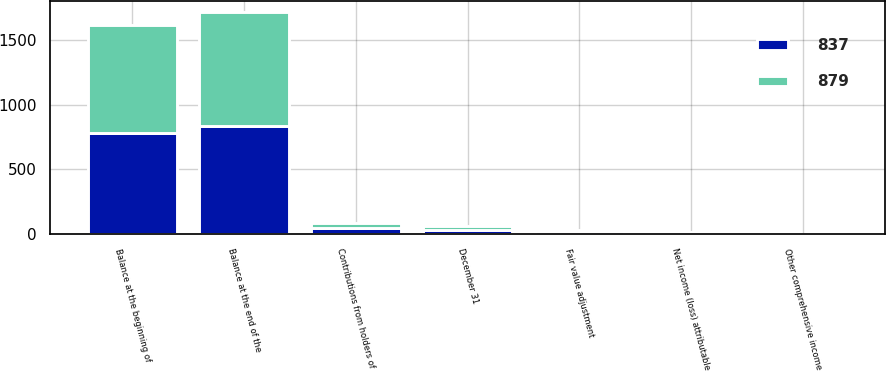Convert chart. <chart><loc_0><loc_0><loc_500><loc_500><stacked_bar_chart><ecel><fcel>December 31<fcel>Balance at the beginning of<fcel>Contributions from holders of<fcel>Net income (loss) attributable<fcel>Fair value adjustment<fcel>Other comprehensive income<fcel>Balance at the end of the<nl><fcel>879<fcel>29.5<fcel>837<fcel>34<fcel>2<fcel>4<fcel>2<fcel>879<nl><fcel>837<fcel>29.5<fcel>782<fcel>50<fcel>14<fcel>25<fcel>2<fcel>837<nl></chart> 